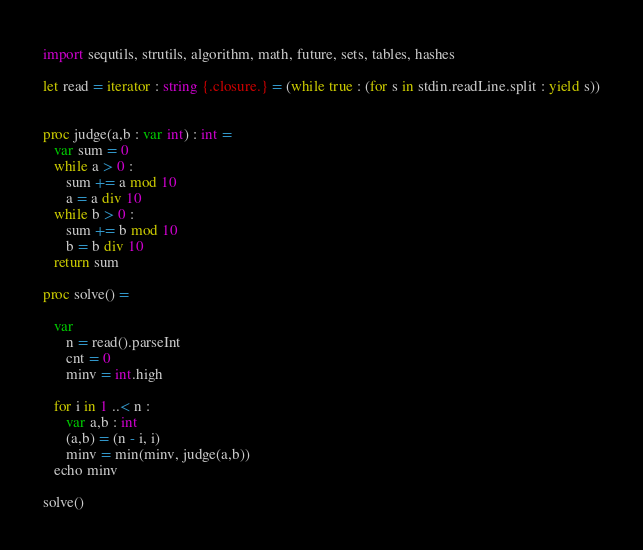Convert code to text. <code><loc_0><loc_0><loc_500><loc_500><_Nim_>import sequtils, strutils, algorithm, math, future, sets, tables, hashes

let read = iterator : string {.closure.} = (while true : (for s in stdin.readLine.split : yield s))


proc judge(a,b : var int) : int = 
   var sum = 0
   while a > 0 : 
      sum += a mod 10
      a = a div 10
   while b > 0 : 
      sum += b mod 10
      b = b div 10
   return sum

proc solve() =
   
   var
      n = read().parseInt
      cnt = 0
      minv = int.high
      
   for i in 1 ..< n :  
      var a,b : int 
      (a,b) = (n - i, i)
      minv = min(minv, judge(a,b))
   echo minv

solve()</code> 